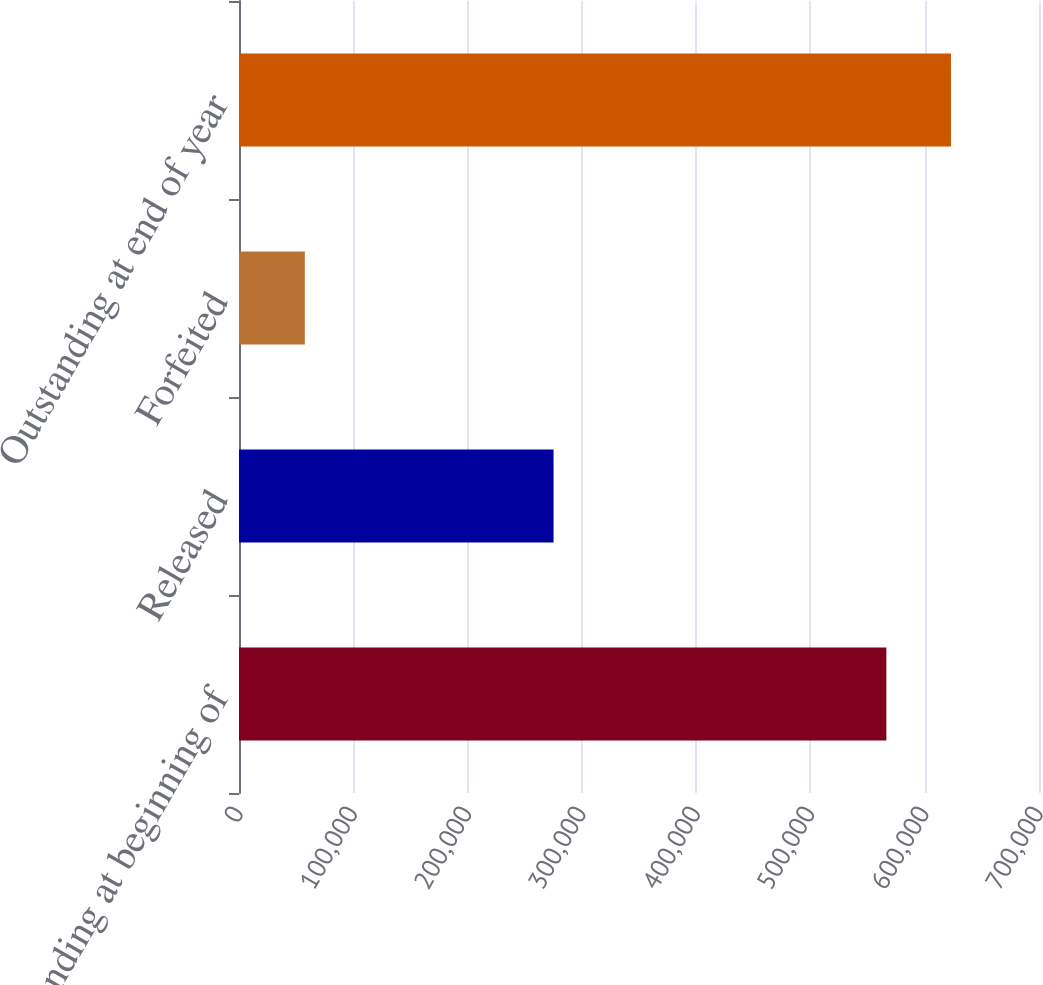<chart> <loc_0><loc_0><loc_500><loc_500><bar_chart><fcel>Outstanding at beginning of<fcel>Released<fcel>Forfeited<fcel>Outstanding at end of year<nl><fcel>566447<fcel>275229<fcel>57597<fcel>622969<nl></chart> 